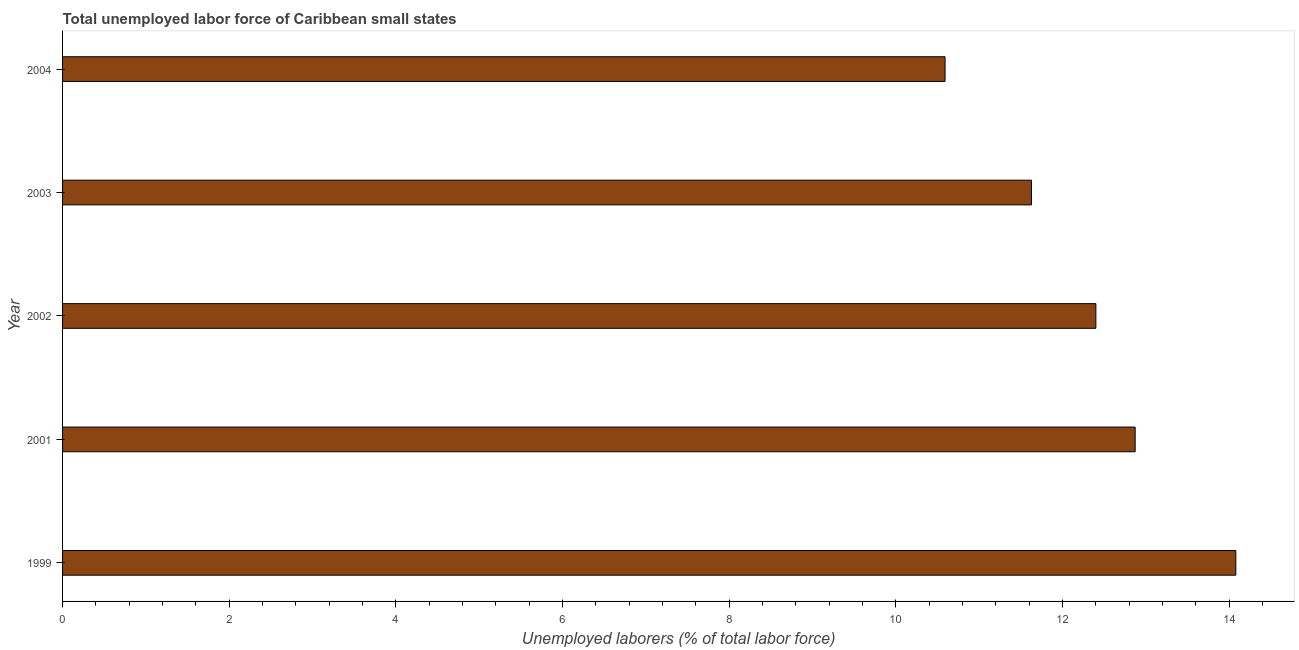Does the graph contain any zero values?
Ensure brevity in your answer.  No. Does the graph contain grids?
Offer a terse response. No. What is the title of the graph?
Your answer should be very brief. Total unemployed labor force of Caribbean small states. What is the label or title of the X-axis?
Ensure brevity in your answer.  Unemployed laborers (% of total labor force). What is the total unemployed labour force in 2003?
Your response must be concise. 11.63. Across all years, what is the maximum total unemployed labour force?
Provide a short and direct response. 14.08. Across all years, what is the minimum total unemployed labour force?
Keep it short and to the point. 10.59. In which year was the total unemployed labour force maximum?
Keep it short and to the point. 1999. What is the sum of the total unemployed labour force?
Your response must be concise. 61.58. What is the difference between the total unemployed labour force in 1999 and 2002?
Keep it short and to the point. 1.68. What is the average total unemployed labour force per year?
Offer a very short reply. 12.31. What is the median total unemployed labour force?
Offer a very short reply. 12.4. In how many years, is the total unemployed labour force greater than 6 %?
Ensure brevity in your answer.  5. What is the ratio of the total unemployed labour force in 1999 to that in 2004?
Keep it short and to the point. 1.33. Is the difference between the total unemployed labour force in 2001 and 2002 greater than the difference between any two years?
Your answer should be compact. No. What is the difference between the highest and the second highest total unemployed labour force?
Your response must be concise. 1.21. What is the difference between the highest and the lowest total unemployed labour force?
Keep it short and to the point. 3.49. In how many years, is the total unemployed labour force greater than the average total unemployed labour force taken over all years?
Offer a very short reply. 3. What is the Unemployed laborers (% of total labor force) of 1999?
Ensure brevity in your answer.  14.08. What is the Unemployed laborers (% of total labor force) of 2001?
Your answer should be compact. 12.87. What is the Unemployed laborers (% of total labor force) in 2002?
Ensure brevity in your answer.  12.4. What is the Unemployed laborers (% of total labor force) in 2003?
Keep it short and to the point. 11.63. What is the Unemployed laborers (% of total labor force) in 2004?
Provide a short and direct response. 10.59. What is the difference between the Unemployed laborers (% of total labor force) in 1999 and 2001?
Your response must be concise. 1.21. What is the difference between the Unemployed laborers (% of total labor force) in 1999 and 2002?
Offer a terse response. 1.68. What is the difference between the Unemployed laborers (% of total labor force) in 1999 and 2003?
Make the answer very short. 2.45. What is the difference between the Unemployed laborers (% of total labor force) in 1999 and 2004?
Offer a terse response. 3.49. What is the difference between the Unemployed laborers (% of total labor force) in 2001 and 2002?
Offer a very short reply. 0.47. What is the difference between the Unemployed laborers (% of total labor force) in 2001 and 2003?
Offer a very short reply. 1.24. What is the difference between the Unemployed laborers (% of total labor force) in 2001 and 2004?
Offer a terse response. 2.28. What is the difference between the Unemployed laborers (% of total labor force) in 2002 and 2003?
Provide a succinct answer. 0.77. What is the difference between the Unemployed laborers (% of total labor force) in 2002 and 2004?
Ensure brevity in your answer.  1.81. What is the difference between the Unemployed laborers (% of total labor force) in 2003 and 2004?
Give a very brief answer. 1.04. What is the ratio of the Unemployed laborers (% of total labor force) in 1999 to that in 2001?
Ensure brevity in your answer.  1.09. What is the ratio of the Unemployed laborers (% of total labor force) in 1999 to that in 2002?
Give a very brief answer. 1.14. What is the ratio of the Unemployed laborers (% of total labor force) in 1999 to that in 2003?
Keep it short and to the point. 1.21. What is the ratio of the Unemployed laborers (% of total labor force) in 1999 to that in 2004?
Make the answer very short. 1.33. What is the ratio of the Unemployed laborers (% of total labor force) in 2001 to that in 2002?
Provide a short and direct response. 1.04. What is the ratio of the Unemployed laborers (% of total labor force) in 2001 to that in 2003?
Your answer should be very brief. 1.11. What is the ratio of the Unemployed laborers (% of total labor force) in 2001 to that in 2004?
Provide a short and direct response. 1.22. What is the ratio of the Unemployed laborers (% of total labor force) in 2002 to that in 2003?
Your response must be concise. 1.07. What is the ratio of the Unemployed laborers (% of total labor force) in 2002 to that in 2004?
Offer a very short reply. 1.17. What is the ratio of the Unemployed laborers (% of total labor force) in 2003 to that in 2004?
Give a very brief answer. 1.1. 